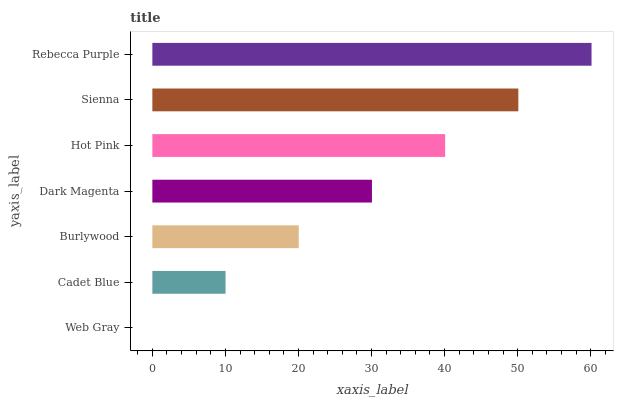Is Web Gray the minimum?
Answer yes or no. Yes. Is Rebecca Purple the maximum?
Answer yes or no. Yes. Is Cadet Blue the minimum?
Answer yes or no. No. Is Cadet Blue the maximum?
Answer yes or no. No. Is Cadet Blue greater than Web Gray?
Answer yes or no. Yes. Is Web Gray less than Cadet Blue?
Answer yes or no. Yes. Is Web Gray greater than Cadet Blue?
Answer yes or no. No. Is Cadet Blue less than Web Gray?
Answer yes or no. No. Is Dark Magenta the high median?
Answer yes or no. Yes. Is Dark Magenta the low median?
Answer yes or no. Yes. Is Rebecca Purple the high median?
Answer yes or no. No. Is Sienna the low median?
Answer yes or no. No. 